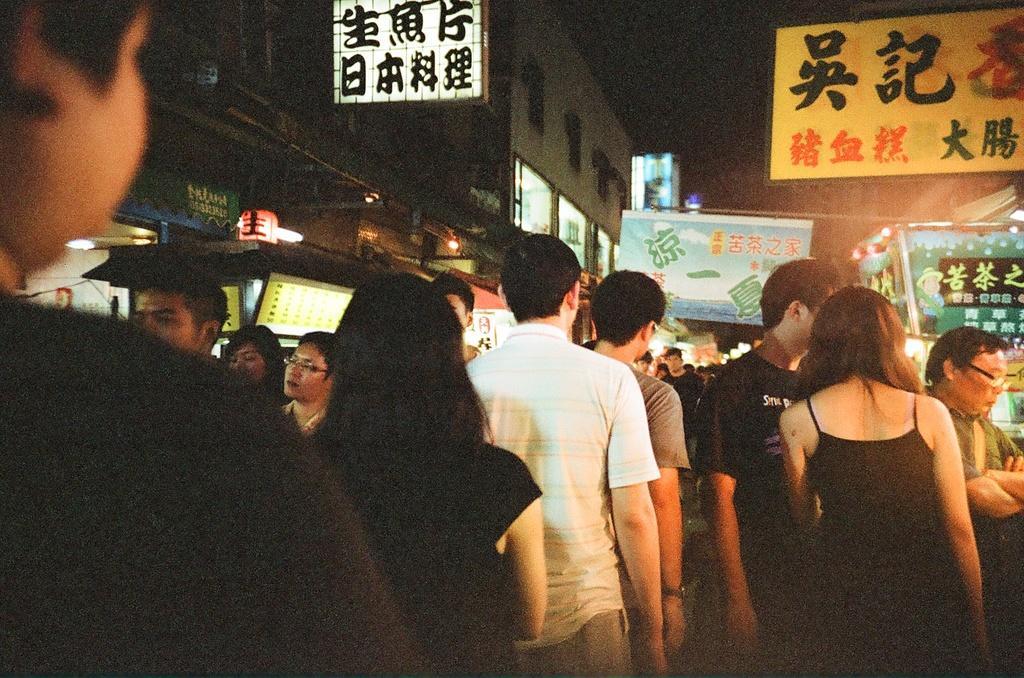Please provide a concise description of this image. In this picture I can observe some people in the middle of the picture. There are men and women in this picture. In the background I can observe buildings. 